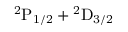Convert formula to latex. <formula><loc_0><loc_0><loc_500><loc_500>{ } ^ { 2 } P _ { 1 / 2 } ^ { 2 } D _ { 3 / 2 }</formula> 